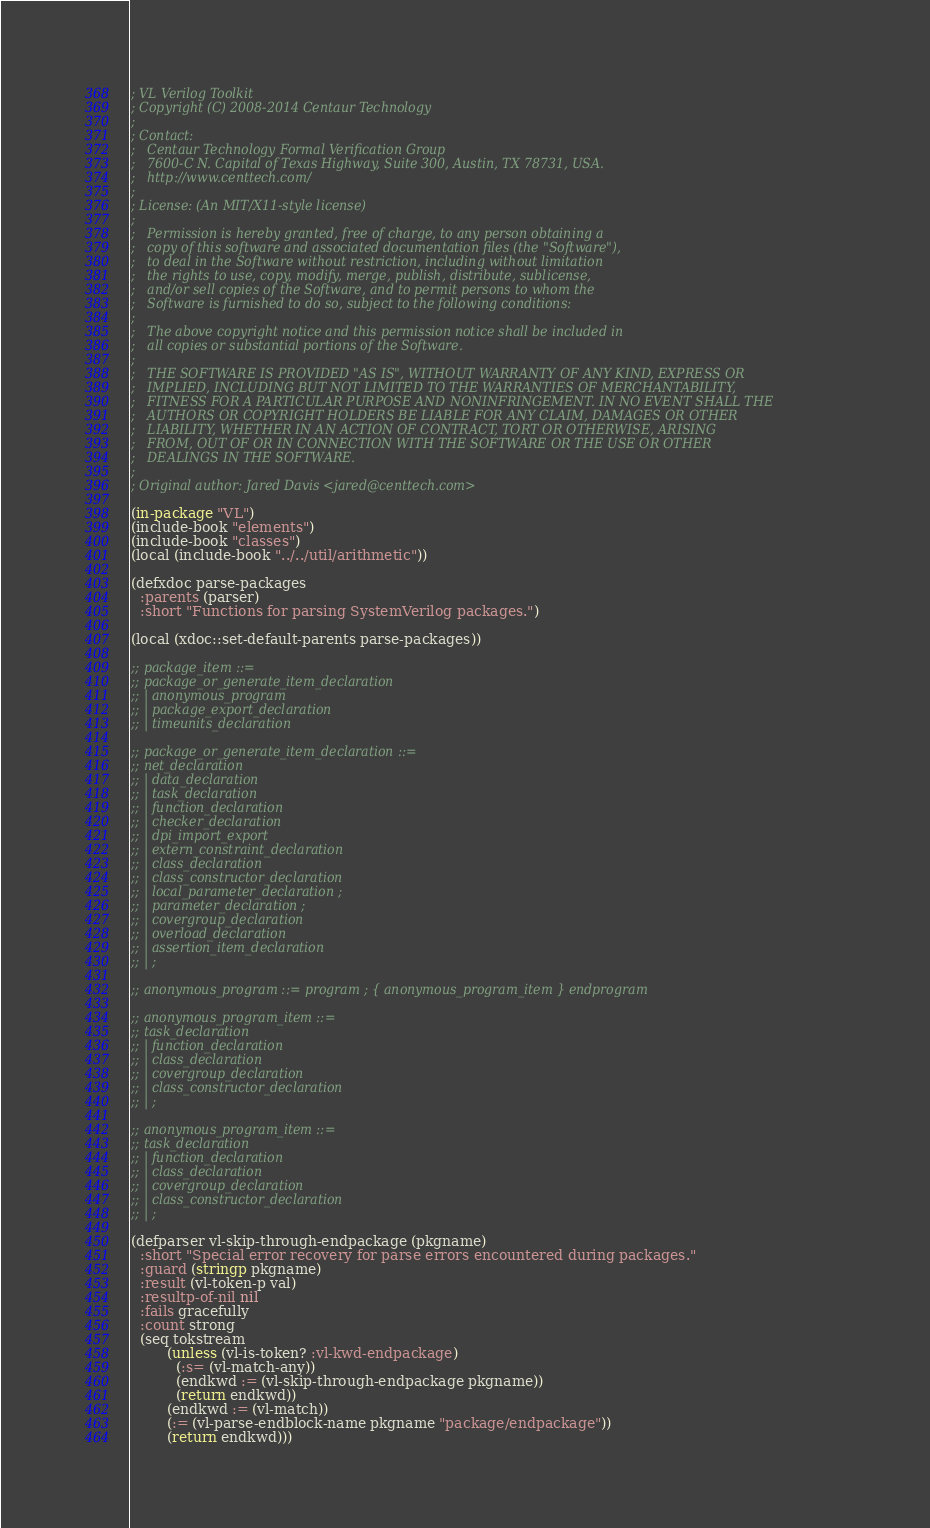Convert code to text. <code><loc_0><loc_0><loc_500><loc_500><_Lisp_>; VL Verilog Toolkit
; Copyright (C) 2008-2014 Centaur Technology
;
; Contact:
;   Centaur Technology Formal Verification Group
;   7600-C N. Capital of Texas Highway, Suite 300, Austin, TX 78731, USA.
;   http://www.centtech.com/
;
; License: (An MIT/X11-style license)
;
;   Permission is hereby granted, free of charge, to any person obtaining a
;   copy of this software and associated documentation files (the "Software"),
;   to deal in the Software without restriction, including without limitation
;   the rights to use, copy, modify, merge, publish, distribute, sublicense,
;   and/or sell copies of the Software, and to permit persons to whom the
;   Software is furnished to do so, subject to the following conditions:
;
;   The above copyright notice and this permission notice shall be included in
;   all copies or substantial portions of the Software.
;
;   THE SOFTWARE IS PROVIDED "AS IS", WITHOUT WARRANTY OF ANY KIND, EXPRESS OR
;   IMPLIED, INCLUDING BUT NOT LIMITED TO THE WARRANTIES OF MERCHANTABILITY,
;   FITNESS FOR A PARTICULAR PURPOSE AND NONINFRINGEMENT. IN NO EVENT SHALL THE
;   AUTHORS OR COPYRIGHT HOLDERS BE LIABLE FOR ANY CLAIM, DAMAGES OR OTHER
;   LIABILITY, WHETHER IN AN ACTION OF CONTRACT, TORT OR OTHERWISE, ARISING
;   FROM, OUT OF OR IN CONNECTION WITH THE SOFTWARE OR THE USE OR OTHER
;   DEALINGS IN THE SOFTWARE.
;
; Original author: Jared Davis <jared@centtech.com>

(in-package "VL")
(include-book "elements")
(include-book "classes")
(local (include-book "../../util/arithmetic"))

(defxdoc parse-packages
  :parents (parser)
  :short "Functions for parsing SystemVerilog packages.")

(local (xdoc::set-default-parents parse-packages))

;; package_item ::=
;; package_or_generate_item_declaration
;; | anonymous_program
;; | package_export_declaration
;; | timeunits_declaration

;; package_or_generate_item_declaration ::=
;; net_declaration
;; | data_declaration
;; | task_declaration
;; | function_declaration
;; | checker_declaration
;; | dpi_import_export
;; | extern_constraint_declaration
;; | class_declaration
;; | class_constructor_declaration
;; | local_parameter_declaration ;
;; | parameter_declaration ;
;; | covergroup_declaration
;; | overload_declaration
;; | assertion_item_declaration
;; | ;

;; anonymous_program ::= program ; { anonymous_program_item } endprogram

;; anonymous_program_item ::=
;; task_declaration
;; | function_declaration
;; | class_declaration
;; | covergroup_declaration
;; | class_constructor_declaration
;; | ;

;; anonymous_program_item ::=
;; task_declaration
;; | function_declaration
;; | class_declaration
;; | covergroup_declaration
;; | class_constructor_declaration
;; | ;

(defparser vl-skip-through-endpackage (pkgname)
  :short "Special error recovery for parse errors encountered during packages."
  :guard (stringp pkgname)
  :result (vl-token-p val)
  :resultp-of-nil nil
  :fails gracefully
  :count strong
  (seq tokstream
        (unless (vl-is-token? :vl-kwd-endpackage)
          (:s= (vl-match-any))
          (endkwd := (vl-skip-through-endpackage pkgname))
          (return endkwd))
        (endkwd := (vl-match))
        (:= (vl-parse-endblock-name pkgname "package/endpackage"))
        (return endkwd)))
</code> 